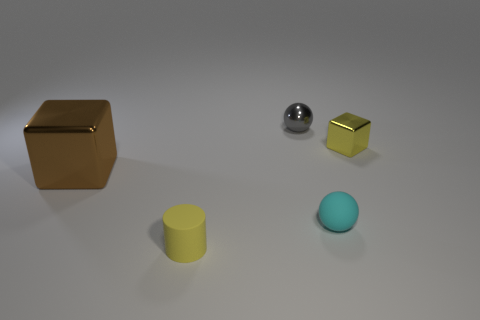There is another big cube that is the same material as the yellow cube; what color is it?
Provide a succinct answer. Brown. How many large red cylinders have the same material as the large thing?
Offer a terse response. 0. There is a small block to the right of the yellow matte cylinder; does it have the same color as the cylinder?
Provide a succinct answer. Yes. What number of other brown metal objects have the same shape as the large brown thing?
Your response must be concise. 0. Are there an equal number of cyan spheres that are to the right of the small rubber ball and small yellow cubes?
Provide a succinct answer. No. What color is the matte sphere that is the same size as the yellow block?
Your answer should be compact. Cyan. Are there any small yellow objects of the same shape as the large brown thing?
Keep it short and to the point. Yes. The object that is on the right side of the small ball to the right of the tiny ball behind the yellow metal cube is made of what material?
Your answer should be compact. Metal. What number of other things are the same size as the cyan thing?
Offer a terse response. 3. What is the color of the big metallic object?
Offer a very short reply. Brown. 